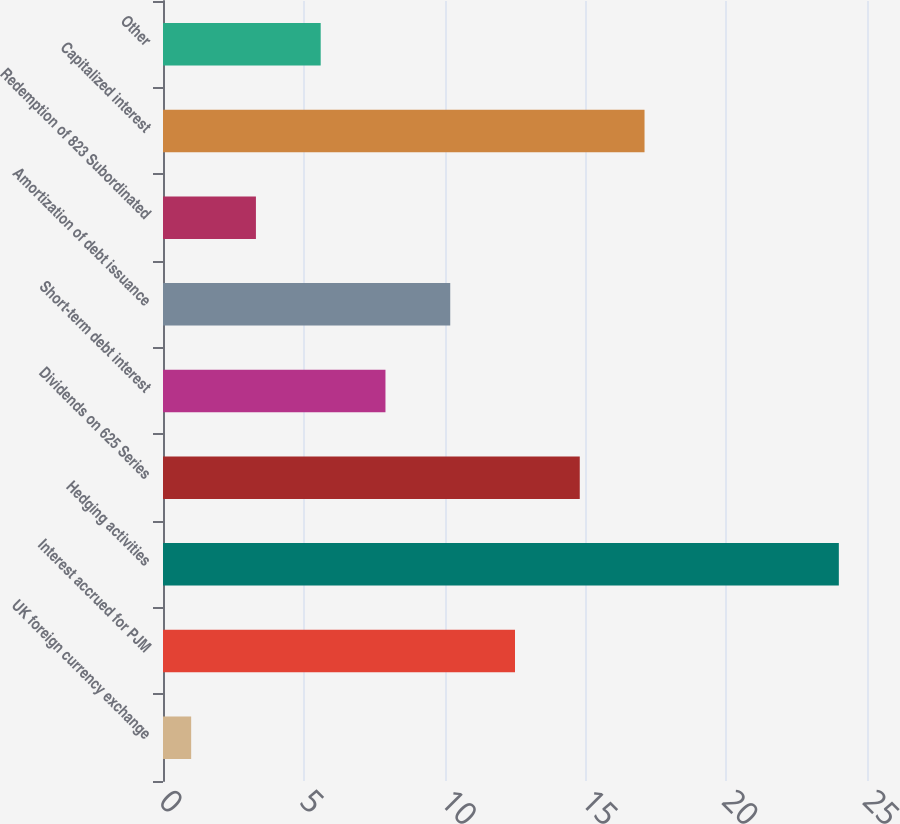<chart> <loc_0><loc_0><loc_500><loc_500><bar_chart><fcel>UK foreign currency exchange<fcel>Interest accrued for PJM<fcel>Hedging activities<fcel>Dividends on 625 Series<fcel>Short-term debt interest<fcel>Amortization of debt issuance<fcel>Redemption of 823 Subordinated<fcel>Capitalized interest<fcel>Other<nl><fcel>1<fcel>12.5<fcel>24<fcel>14.8<fcel>7.9<fcel>10.2<fcel>3.3<fcel>17.1<fcel>5.6<nl></chart> 